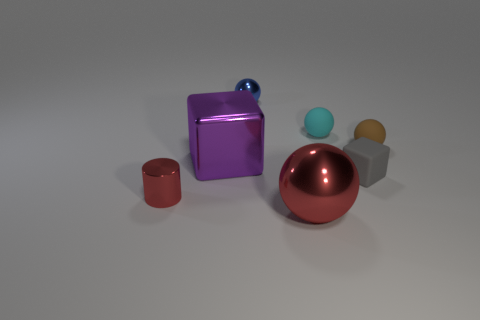There is a block that is made of the same material as the brown sphere; what color is it?
Provide a succinct answer. Gray. There is a small blue object; what shape is it?
Provide a succinct answer. Sphere. There is a small object to the left of the purple cube; what material is it?
Your answer should be very brief. Metal. Are there any large matte objects that have the same color as the shiny cylinder?
Ensure brevity in your answer.  No. What is the shape of the blue object that is the same size as the brown rubber sphere?
Your answer should be compact. Sphere. There is a big thing on the right side of the small metallic ball; what is its color?
Offer a terse response. Red. There is a big object behind the tiny gray thing; is there a tiny brown rubber ball that is in front of it?
Provide a succinct answer. No. How many objects are matte objects that are to the left of the gray thing or large green blocks?
Offer a terse response. 1. Is there any other thing that has the same size as the purple shiny object?
Give a very brief answer. Yes. What is the material of the red object that is left of the metal sphere that is left of the large sphere?
Make the answer very short. Metal. 